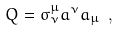<formula> <loc_0><loc_0><loc_500><loc_500>Q = \sigma _ { \nu } ^ { \mu } a ^ { \nu } a _ { \mu } \ ,</formula> 